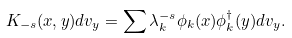Convert formula to latex. <formula><loc_0><loc_0><loc_500><loc_500>K _ { - s } ( x , y ) d v _ { y } = \sum \lambda _ { k } ^ { - s } \phi _ { k } ( x ) \phi _ { k } ^ { \dag } ( y ) d v _ { y } .</formula> 